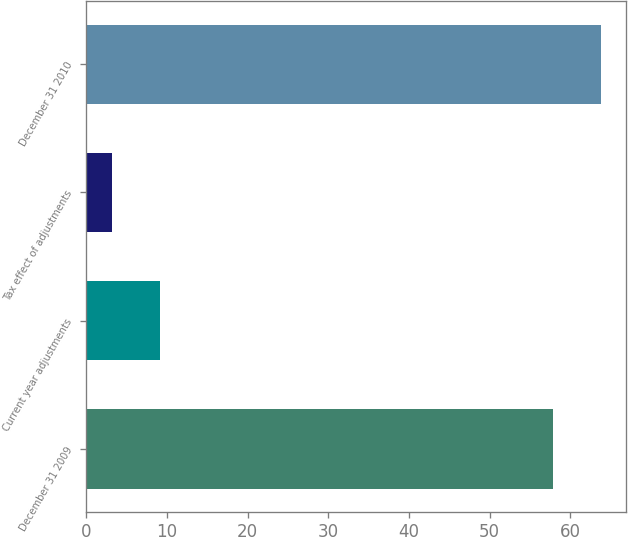Convert chart to OTSL. <chart><loc_0><loc_0><loc_500><loc_500><bar_chart><fcel>December 31 2009<fcel>Current year adjustments<fcel>Tax effect of adjustments<fcel>December 31 2010<nl><fcel>57.8<fcel>9.17<fcel>3.2<fcel>63.77<nl></chart> 